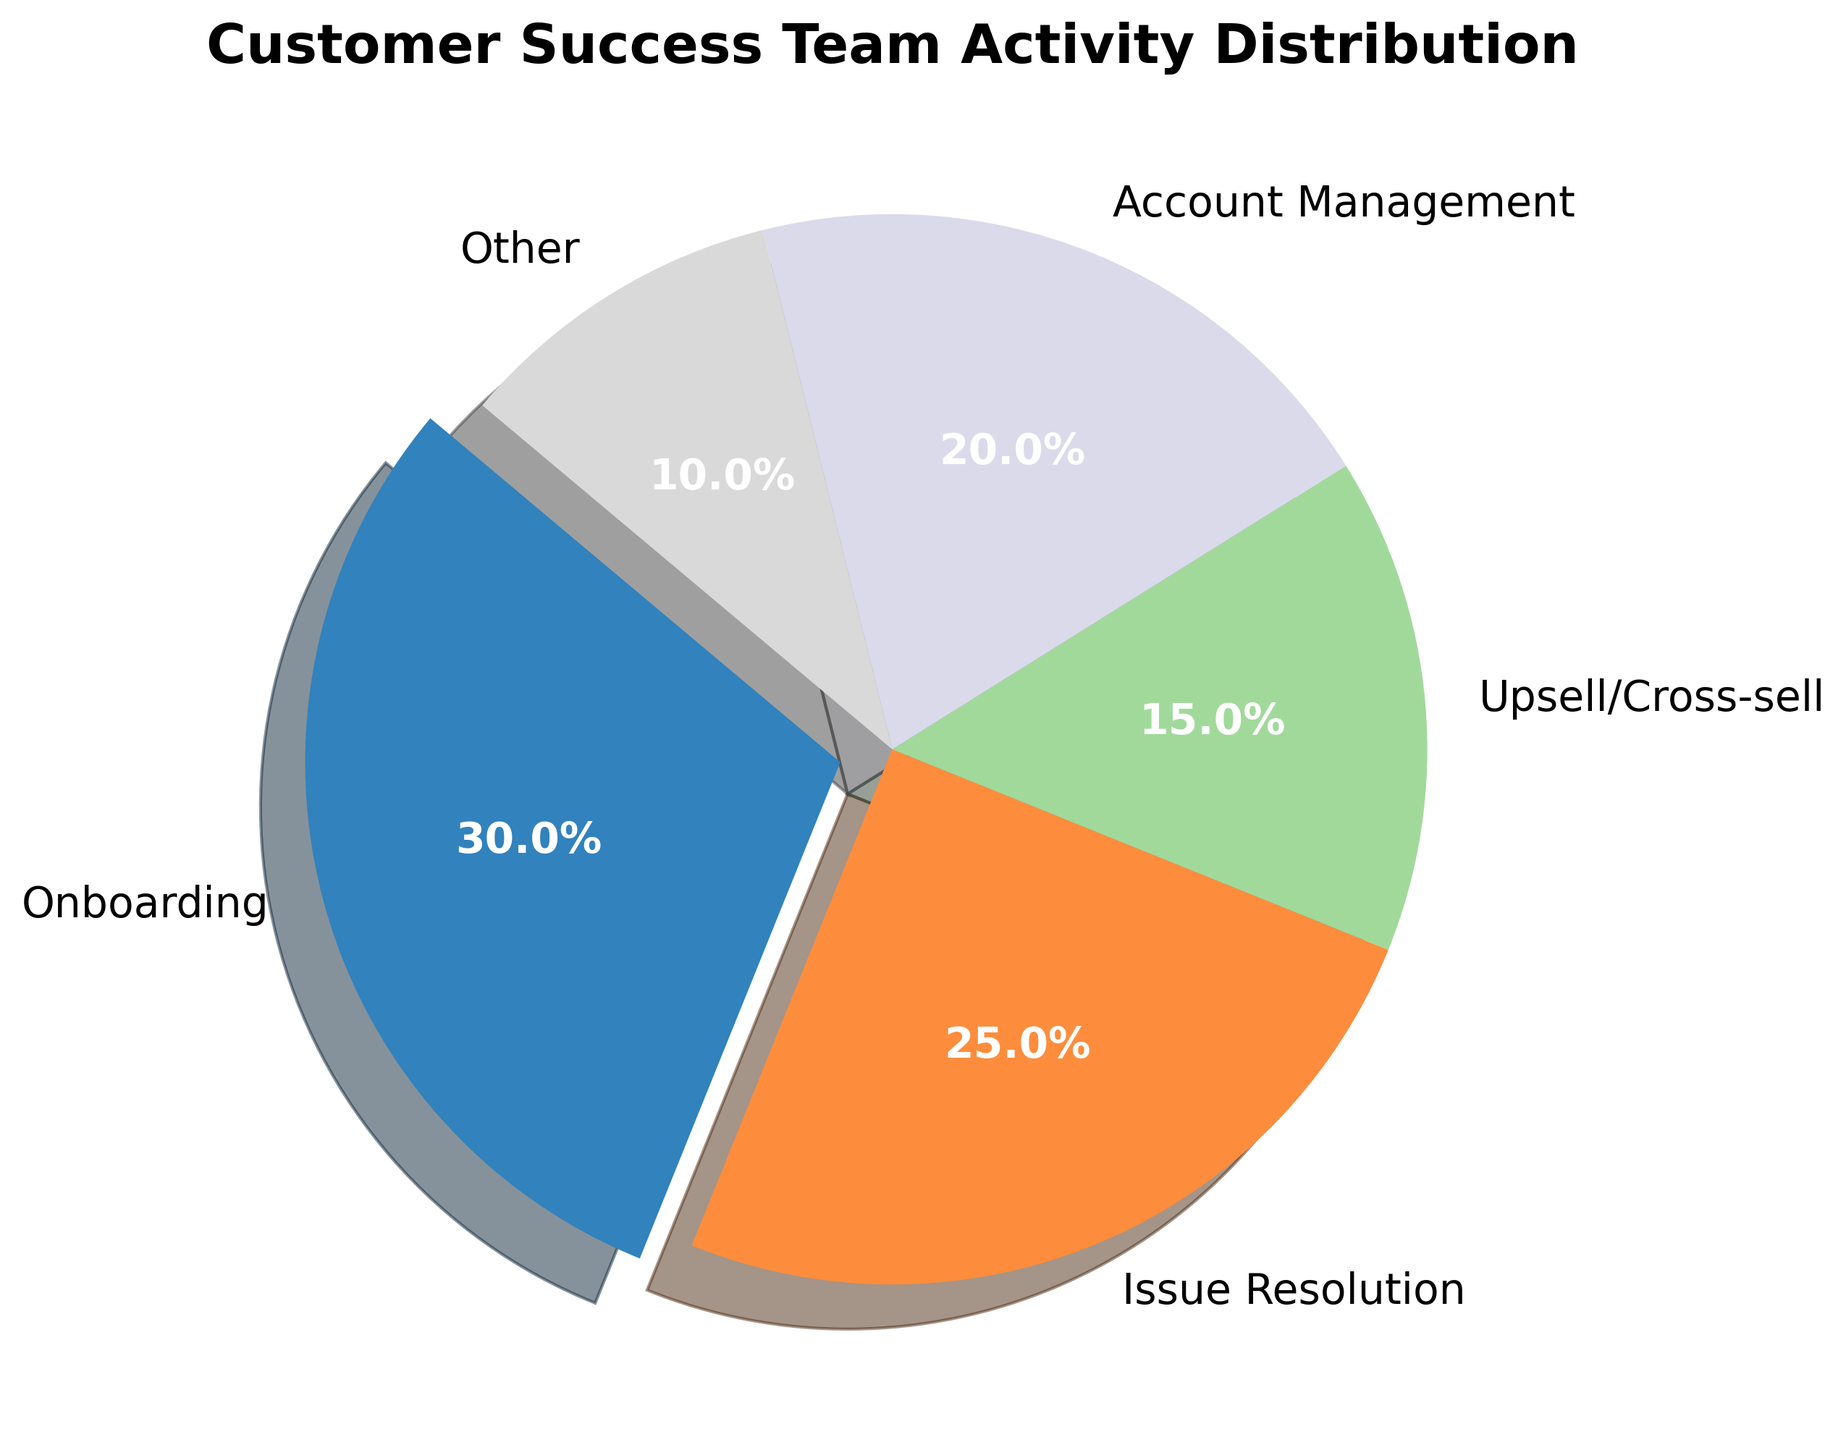What percentage of the Customer Success Team’s activities is dedicated to Onboarding? Look at the section labeled 'Onboarding' in the pie chart. The percentage value given is 30%.
Answer: 30% What is the combined percentage of Issue Resolution and Account Management activities? Find the percentage values for Issue Resolution (25%) and Account Management (20%), then add them together: 25% + 20% = 45%.
Answer: 45% Which activity takes up the smallest percentage of the Customer Success Team's time? Identify the smallest section of the pie chart. The 'Other' category is the smallest with 10%.
Answer: Other Is the time spent on Onboarding greater than the combined time spent on Upsell/Cross-sell and Other activities? Onboarding is 30%. Sum the percentages of Upsell/Cross-sell (15%) and Other (10%): 15% + 10% = 25%. Compare 30% with 25%. Since 30% is greater, Onboarding takes more time.
Answer: Yes By how much percentage does the time spent on Issue Resolution exceed Upsell/Cross-sell activities? Find the difference between Issue Resolution (25%) and Upsell/Cross-sell (15%) using subtraction: 25% - 15% = 10%.
Answer: 10% What is the second most time-consuming activity for the Customer Success Team? Identify the second-largest section of the pie chart. Issue Resolution is the second-largest with 25%.
Answer: Issue Resolution If the percentages of Onboarding and Issue Resolution were switched, what would be the new percentage for Account Management compared to its current value? If Onboarding and Issue Resolution swap percentages, Onboarding becomes 25% and Issue Resolution becomes 30%. The percentage for Account Management remains the same (20%) and does not change compared to its current value.
Answer: Unchanged What color is used to represent the Account Management activity in the pie chart? Look at the section labeled 'Account Management' and identify its color. In the provided code, the color for Account Management will correspond to one of the colors in the 'tab20c' colormap, specifically at the index where Account Management is. Assume a generic color assignment such as red, or if detailed, it is determined by plotting it.
Answer: Answer based on actual color: e.g., [Color] How many activities have a percentage greater than or equal to 20%? Examine each category's percentage. Onboarding (30%), Issue Resolution (25%), and Account Management (20%) are all equal to or greater than 20%. Therefore, the count is 3.
Answer: 3 What is the average percentage of time spent across all activities? Add all categories' percentages and divide by the number of categories: (30% + 25% + 15% + 20% + 10%) / 5 = 20%.
Answer: 20% 